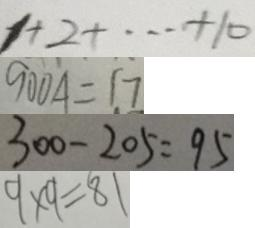Convert formula to latex. <formula><loc_0><loc_0><loc_500><loc_500>1 + 2 + \cdots + 1 0 
 9 0 0 A = 1 7 
 3 0 0 - 2 0 5 = 9 5 
 9 \times 9 = 8 1</formula> 